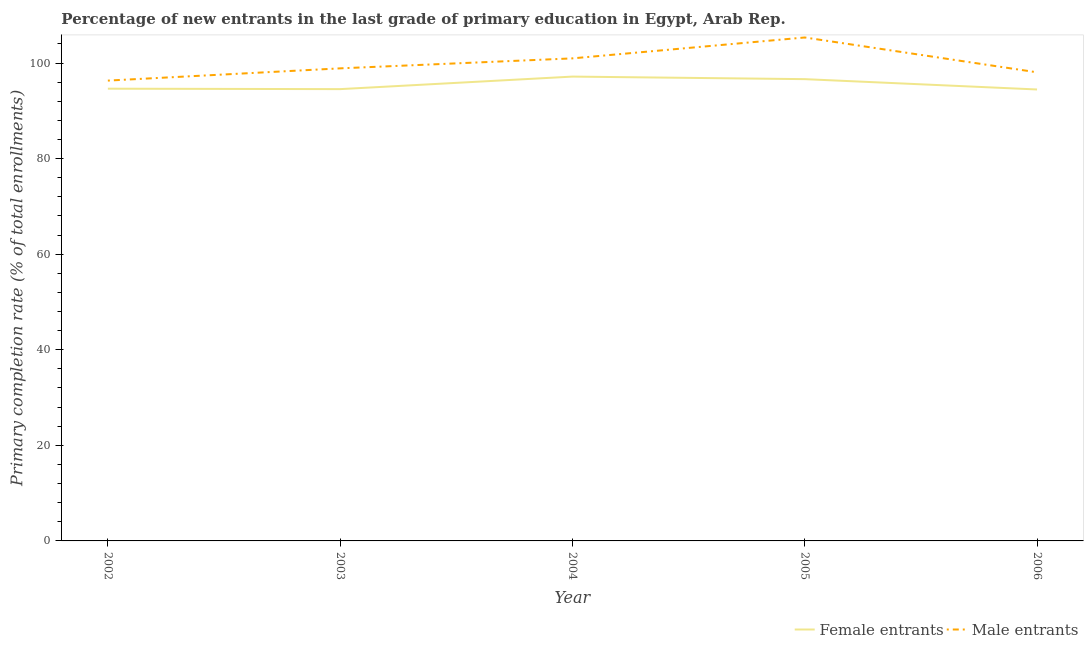What is the primary completion rate of male entrants in 2005?
Your response must be concise. 105.35. Across all years, what is the maximum primary completion rate of male entrants?
Offer a terse response. 105.35. Across all years, what is the minimum primary completion rate of female entrants?
Your response must be concise. 94.47. In which year was the primary completion rate of male entrants maximum?
Provide a succinct answer. 2005. What is the total primary completion rate of male entrants in the graph?
Provide a succinct answer. 499.59. What is the difference between the primary completion rate of male entrants in 2005 and that in 2006?
Offer a very short reply. 7.29. What is the difference between the primary completion rate of female entrants in 2006 and the primary completion rate of male entrants in 2002?
Your answer should be very brief. -1.86. What is the average primary completion rate of male entrants per year?
Keep it short and to the point. 99.92. In the year 2003, what is the difference between the primary completion rate of male entrants and primary completion rate of female entrants?
Your answer should be very brief. 4.35. In how many years, is the primary completion rate of female entrants greater than 68 %?
Provide a short and direct response. 5. What is the ratio of the primary completion rate of male entrants in 2004 to that in 2005?
Your response must be concise. 0.96. Is the primary completion rate of female entrants in 2004 less than that in 2006?
Your answer should be very brief. No. Is the difference between the primary completion rate of female entrants in 2002 and 2004 greater than the difference between the primary completion rate of male entrants in 2002 and 2004?
Give a very brief answer. Yes. What is the difference between the highest and the second highest primary completion rate of female entrants?
Your answer should be compact. 0.53. What is the difference between the highest and the lowest primary completion rate of female entrants?
Your response must be concise. 2.7. In how many years, is the primary completion rate of male entrants greater than the average primary completion rate of male entrants taken over all years?
Ensure brevity in your answer.  2. Is the sum of the primary completion rate of male entrants in 2003 and 2005 greater than the maximum primary completion rate of female entrants across all years?
Your response must be concise. Yes. Is the primary completion rate of female entrants strictly greater than the primary completion rate of male entrants over the years?
Your response must be concise. No. How many lines are there?
Give a very brief answer. 2. How many years are there in the graph?
Give a very brief answer. 5. How are the legend labels stacked?
Your answer should be compact. Horizontal. What is the title of the graph?
Keep it short and to the point. Percentage of new entrants in the last grade of primary education in Egypt, Arab Rep. Does "Commercial service exports" appear as one of the legend labels in the graph?
Your response must be concise. No. What is the label or title of the Y-axis?
Make the answer very short. Primary completion rate (% of total enrollments). What is the Primary completion rate (% of total enrollments) of Female entrants in 2002?
Offer a terse response. 94.63. What is the Primary completion rate (% of total enrollments) in Male entrants in 2002?
Give a very brief answer. 96.32. What is the Primary completion rate (% of total enrollments) of Female entrants in 2003?
Provide a succinct answer. 94.54. What is the Primary completion rate (% of total enrollments) in Male entrants in 2003?
Your response must be concise. 98.89. What is the Primary completion rate (% of total enrollments) in Female entrants in 2004?
Your response must be concise. 97.16. What is the Primary completion rate (% of total enrollments) of Male entrants in 2004?
Make the answer very short. 100.97. What is the Primary completion rate (% of total enrollments) in Female entrants in 2005?
Provide a succinct answer. 96.63. What is the Primary completion rate (% of total enrollments) in Male entrants in 2005?
Provide a short and direct response. 105.35. What is the Primary completion rate (% of total enrollments) in Female entrants in 2006?
Make the answer very short. 94.47. What is the Primary completion rate (% of total enrollments) in Male entrants in 2006?
Your response must be concise. 98.06. Across all years, what is the maximum Primary completion rate (% of total enrollments) of Female entrants?
Offer a very short reply. 97.16. Across all years, what is the maximum Primary completion rate (% of total enrollments) of Male entrants?
Make the answer very short. 105.35. Across all years, what is the minimum Primary completion rate (% of total enrollments) of Female entrants?
Give a very brief answer. 94.47. Across all years, what is the minimum Primary completion rate (% of total enrollments) of Male entrants?
Your answer should be compact. 96.32. What is the total Primary completion rate (% of total enrollments) in Female entrants in the graph?
Your response must be concise. 477.43. What is the total Primary completion rate (% of total enrollments) in Male entrants in the graph?
Provide a succinct answer. 499.59. What is the difference between the Primary completion rate (% of total enrollments) of Female entrants in 2002 and that in 2003?
Provide a short and direct response. 0.09. What is the difference between the Primary completion rate (% of total enrollments) in Male entrants in 2002 and that in 2003?
Ensure brevity in your answer.  -2.56. What is the difference between the Primary completion rate (% of total enrollments) in Female entrants in 2002 and that in 2004?
Provide a succinct answer. -2.53. What is the difference between the Primary completion rate (% of total enrollments) of Male entrants in 2002 and that in 2004?
Ensure brevity in your answer.  -4.65. What is the difference between the Primary completion rate (% of total enrollments) in Female entrants in 2002 and that in 2005?
Provide a succinct answer. -2. What is the difference between the Primary completion rate (% of total enrollments) of Male entrants in 2002 and that in 2005?
Provide a short and direct response. -9.02. What is the difference between the Primary completion rate (% of total enrollments) of Female entrants in 2002 and that in 2006?
Make the answer very short. 0.16. What is the difference between the Primary completion rate (% of total enrollments) in Male entrants in 2002 and that in 2006?
Provide a succinct answer. -1.73. What is the difference between the Primary completion rate (% of total enrollments) in Female entrants in 2003 and that in 2004?
Your response must be concise. -2.62. What is the difference between the Primary completion rate (% of total enrollments) in Male entrants in 2003 and that in 2004?
Make the answer very short. -2.09. What is the difference between the Primary completion rate (% of total enrollments) of Female entrants in 2003 and that in 2005?
Your response must be concise. -2.09. What is the difference between the Primary completion rate (% of total enrollments) of Male entrants in 2003 and that in 2005?
Your answer should be compact. -6.46. What is the difference between the Primary completion rate (% of total enrollments) in Female entrants in 2003 and that in 2006?
Give a very brief answer. 0.07. What is the difference between the Primary completion rate (% of total enrollments) in Male entrants in 2003 and that in 2006?
Your response must be concise. 0.83. What is the difference between the Primary completion rate (% of total enrollments) in Female entrants in 2004 and that in 2005?
Offer a terse response. 0.53. What is the difference between the Primary completion rate (% of total enrollments) of Male entrants in 2004 and that in 2005?
Your response must be concise. -4.37. What is the difference between the Primary completion rate (% of total enrollments) of Female entrants in 2004 and that in 2006?
Your response must be concise. 2.7. What is the difference between the Primary completion rate (% of total enrollments) of Male entrants in 2004 and that in 2006?
Offer a terse response. 2.92. What is the difference between the Primary completion rate (% of total enrollments) in Female entrants in 2005 and that in 2006?
Keep it short and to the point. 2.16. What is the difference between the Primary completion rate (% of total enrollments) of Male entrants in 2005 and that in 2006?
Your response must be concise. 7.29. What is the difference between the Primary completion rate (% of total enrollments) in Female entrants in 2002 and the Primary completion rate (% of total enrollments) in Male entrants in 2003?
Your response must be concise. -4.26. What is the difference between the Primary completion rate (% of total enrollments) of Female entrants in 2002 and the Primary completion rate (% of total enrollments) of Male entrants in 2004?
Your answer should be very brief. -6.34. What is the difference between the Primary completion rate (% of total enrollments) of Female entrants in 2002 and the Primary completion rate (% of total enrollments) of Male entrants in 2005?
Ensure brevity in your answer.  -10.72. What is the difference between the Primary completion rate (% of total enrollments) of Female entrants in 2002 and the Primary completion rate (% of total enrollments) of Male entrants in 2006?
Provide a succinct answer. -3.43. What is the difference between the Primary completion rate (% of total enrollments) in Female entrants in 2003 and the Primary completion rate (% of total enrollments) in Male entrants in 2004?
Keep it short and to the point. -6.43. What is the difference between the Primary completion rate (% of total enrollments) of Female entrants in 2003 and the Primary completion rate (% of total enrollments) of Male entrants in 2005?
Keep it short and to the point. -10.81. What is the difference between the Primary completion rate (% of total enrollments) in Female entrants in 2003 and the Primary completion rate (% of total enrollments) in Male entrants in 2006?
Ensure brevity in your answer.  -3.52. What is the difference between the Primary completion rate (% of total enrollments) in Female entrants in 2004 and the Primary completion rate (% of total enrollments) in Male entrants in 2005?
Your answer should be very brief. -8.19. What is the difference between the Primary completion rate (% of total enrollments) of Female entrants in 2004 and the Primary completion rate (% of total enrollments) of Male entrants in 2006?
Your response must be concise. -0.9. What is the difference between the Primary completion rate (% of total enrollments) in Female entrants in 2005 and the Primary completion rate (% of total enrollments) in Male entrants in 2006?
Provide a succinct answer. -1.43. What is the average Primary completion rate (% of total enrollments) of Female entrants per year?
Offer a terse response. 95.49. What is the average Primary completion rate (% of total enrollments) of Male entrants per year?
Your answer should be very brief. 99.92. In the year 2002, what is the difference between the Primary completion rate (% of total enrollments) of Female entrants and Primary completion rate (% of total enrollments) of Male entrants?
Give a very brief answer. -1.69. In the year 2003, what is the difference between the Primary completion rate (% of total enrollments) in Female entrants and Primary completion rate (% of total enrollments) in Male entrants?
Provide a succinct answer. -4.35. In the year 2004, what is the difference between the Primary completion rate (% of total enrollments) in Female entrants and Primary completion rate (% of total enrollments) in Male entrants?
Your answer should be compact. -3.81. In the year 2005, what is the difference between the Primary completion rate (% of total enrollments) in Female entrants and Primary completion rate (% of total enrollments) in Male entrants?
Your response must be concise. -8.72. In the year 2006, what is the difference between the Primary completion rate (% of total enrollments) in Female entrants and Primary completion rate (% of total enrollments) in Male entrants?
Give a very brief answer. -3.59. What is the ratio of the Primary completion rate (% of total enrollments) in Male entrants in 2002 to that in 2003?
Ensure brevity in your answer.  0.97. What is the ratio of the Primary completion rate (% of total enrollments) of Female entrants in 2002 to that in 2004?
Provide a succinct answer. 0.97. What is the ratio of the Primary completion rate (% of total enrollments) of Male entrants in 2002 to that in 2004?
Make the answer very short. 0.95. What is the ratio of the Primary completion rate (% of total enrollments) in Female entrants in 2002 to that in 2005?
Your answer should be compact. 0.98. What is the ratio of the Primary completion rate (% of total enrollments) of Male entrants in 2002 to that in 2005?
Your answer should be compact. 0.91. What is the ratio of the Primary completion rate (% of total enrollments) in Female entrants in 2002 to that in 2006?
Give a very brief answer. 1. What is the ratio of the Primary completion rate (% of total enrollments) in Male entrants in 2002 to that in 2006?
Ensure brevity in your answer.  0.98. What is the ratio of the Primary completion rate (% of total enrollments) of Male entrants in 2003 to that in 2004?
Your response must be concise. 0.98. What is the ratio of the Primary completion rate (% of total enrollments) in Female entrants in 2003 to that in 2005?
Give a very brief answer. 0.98. What is the ratio of the Primary completion rate (% of total enrollments) of Male entrants in 2003 to that in 2005?
Your answer should be compact. 0.94. What is the ratio of the Primary completion rate (% of total enrollments) in Female entrants in 2003 to that in 2006?
Offer a terse response. 1. What is the ratio of the Primary completion rate (% of total enrollments) of Male entrants in 2003 to that in 2006?
Offer a terse response. 1.01. What is the ratio of the Primary completion rate (% of total enrollments) in Female entrants in 2004 to that in 2005?
Your answer should be very brief. 1.01. What is the ratio of the Primary completion rate (% of total enrollments) in Male entrants in 2004 to that in 2005?
Keep it short and to the point. 0.96. What is the ratio of the Primary completion rate (% of total enrollments) of Female entrants in 2004 to that in 2006?
Ensure brevity in your answer.  1.03. What is the ratio of the Primary completion rate (% of total enrollments) in Male entrants in 2004 to that in 2006?
Ensure brevity in your answer.  1.03. What is the ratio of the Primary completion rate (% of total enrollments) in Female entrants in 2005 to that in 2006?
Offer a very short reply. 1.02. What is the ratio of the Primary completion rate (% of total enrollments) of Male entrants in 2005 to that in 2006?
Your answer should be compact. 1.07. What is the difference between the highest and the second highest Primary completion rate (% of total enrollments) of Female entrants?
Offer a terse response. 0.53. What is the difference between the highest and the second highest Primary completion rate (% of total enrollments) in Male entrants?
Offer a terse response. 4.37. What is the difference between the highest and the lowest Primary completion rate (% of total enrollments) in Female entrants?
Make the answer very short. 2.7. What is the difference between the highest and the lowest Primary completion rate (% of total enrollments) of Male entrants?
Offer a very short reply. 9.02. 